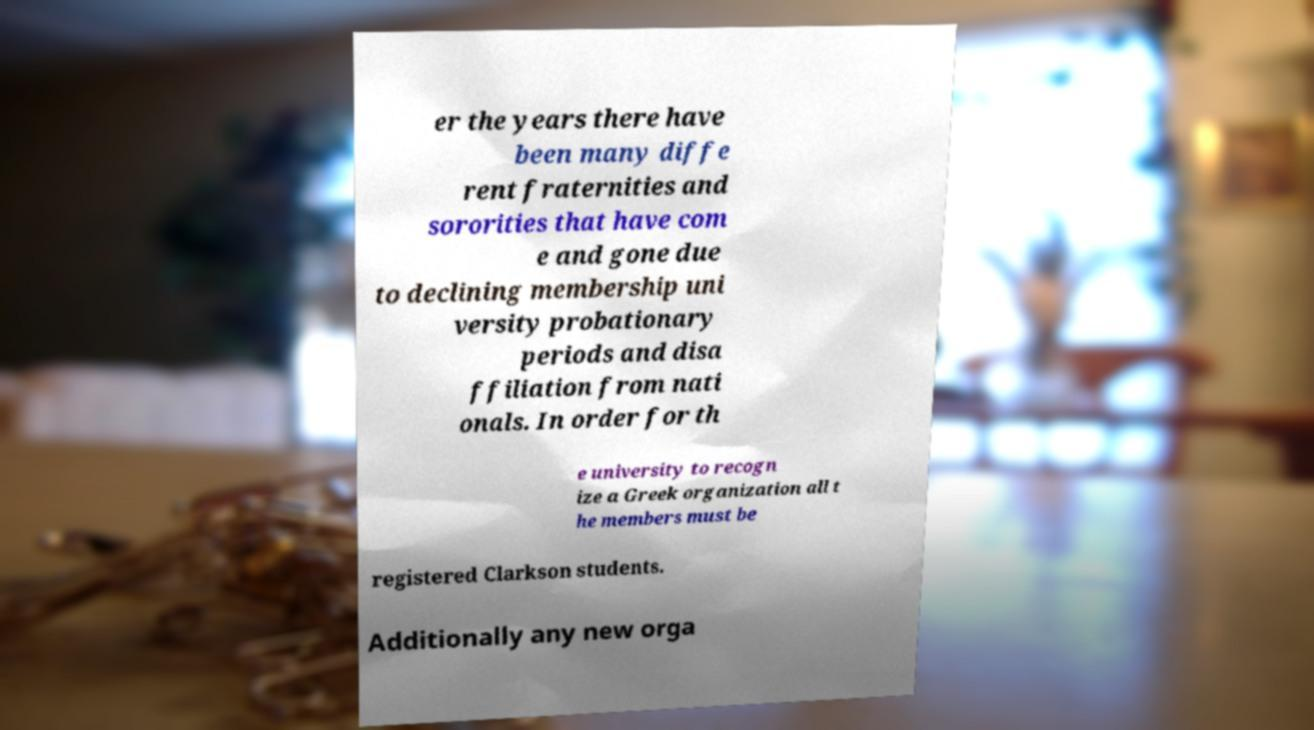What messages or text are displayed in this image? I need them in a readable, typed format. er the years there have been many diffe rent fraternities and sororities that have com e and gone due to declining membership uni versity probationary periods and disa ffiliation from nati onals. In order for th e university to recogn ize a Greek organization all t he members must be registered Clarkson students. Additionally any new orga 